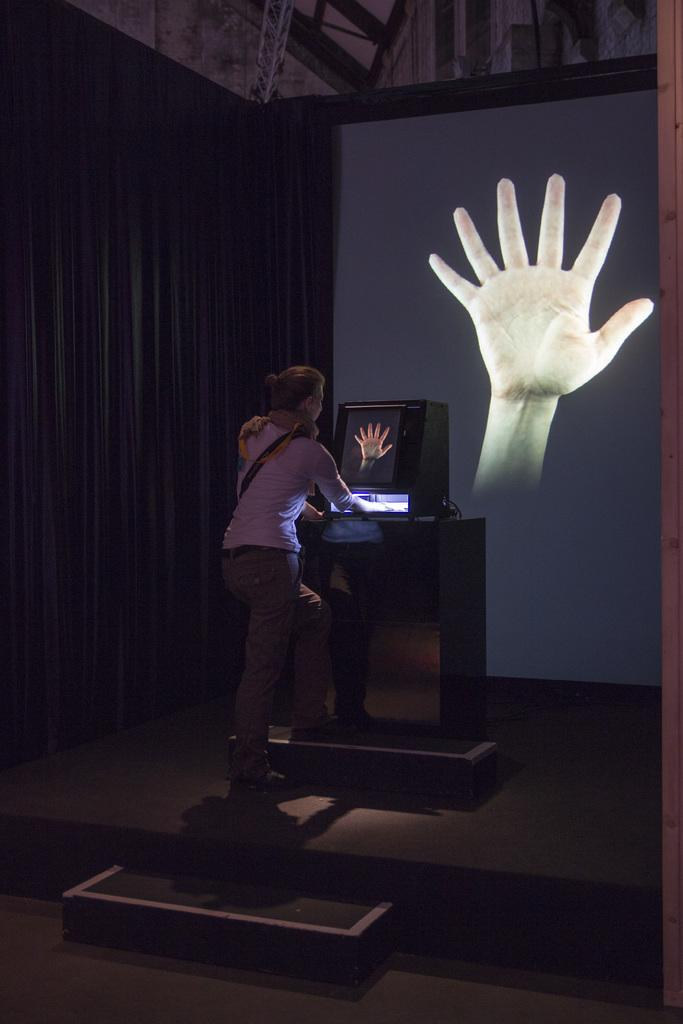What is the woman doing in the image? The woman is standing in the image with her hand under a light. What is the woman interacting with in the image? The woman is standing in front of a screen. What can be seen at the left side of the image? There is a curtain at the left side of the image. How many tomatoes are on the island in the image? There are no tomatoes or islands present in the image. 